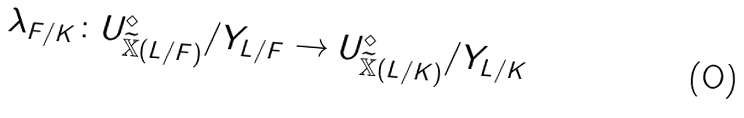<formula> <loc_0><loc_0><loc_500><loc_500>\lambda _ { F / K } \colon U _ { \widetilde { \mathbb { X } } ( L / F ) } ^ { \diamond } / Y _ { L / F } \rightarrow U _ { \widetilde { \mathbb { X } } ( L / K ) } ^ { \diamond } / Y _ { L / K }</formula> 